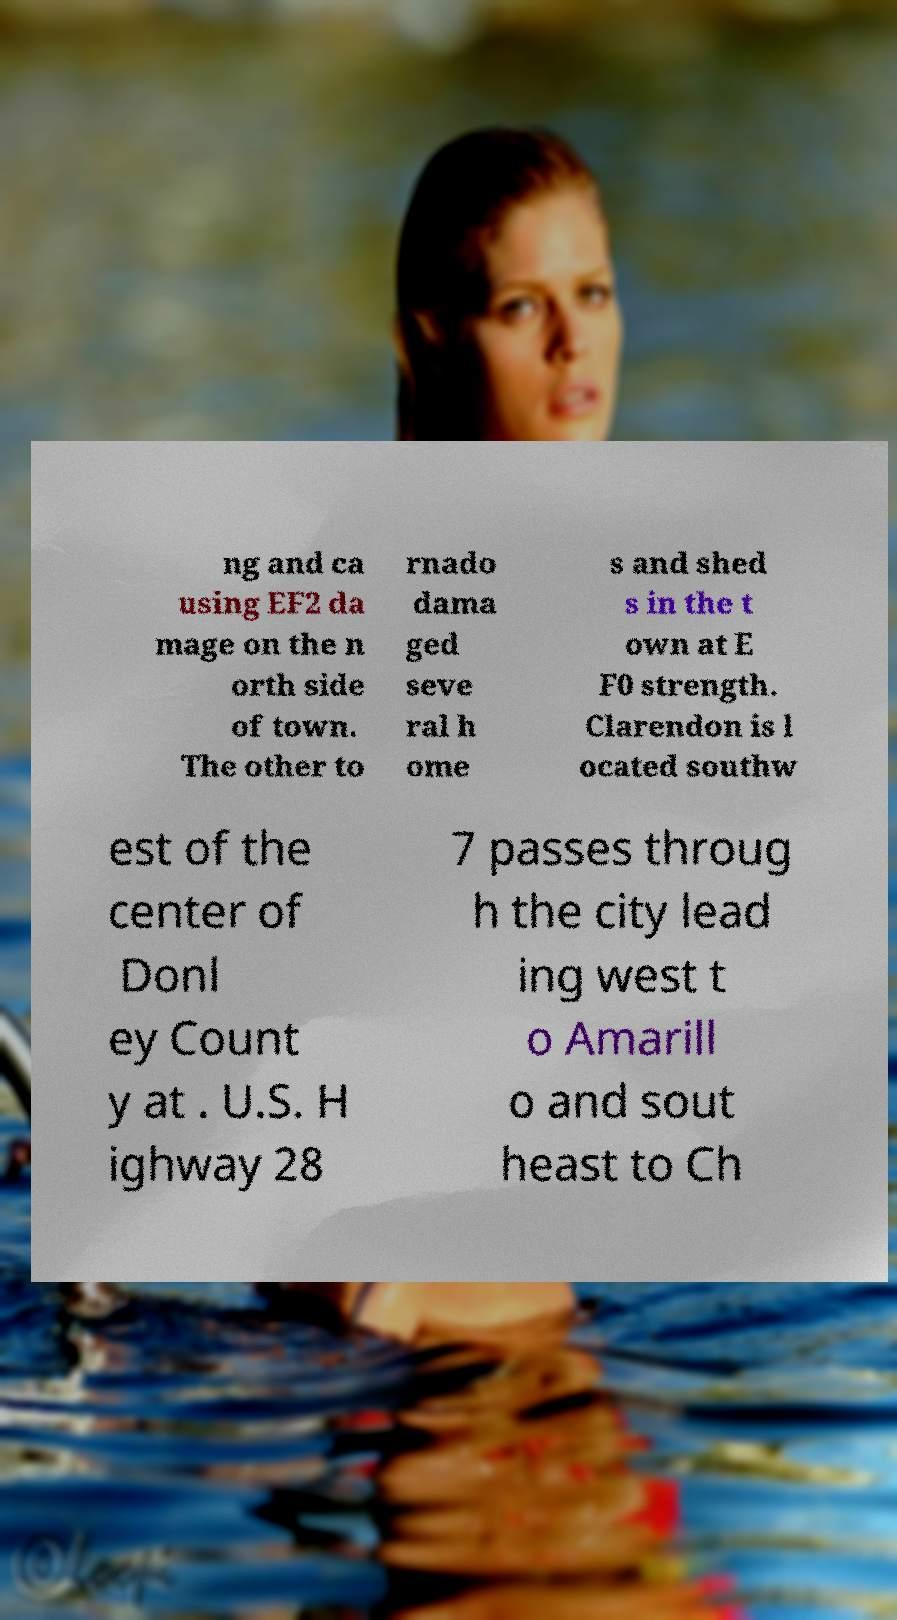I need the written content from this picture converted into text. Can you do that? ng and ca using EF2 da mage on the n orth side of town. The other to rnado dama ged seve ral h ome s and shed s in the t own at E F0 strength. Clarendon is l ocated southw est of the center of Donl ey Count y at . U.S. H ighway 28 7 passes throug h the city lead ing west t o Amarill o and sout heast to Ch 